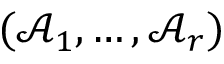<formula> <loc_0><loc_0><loc_500><loc_500>( { \mathcal { A } } _ { 1 } , \dots , { \mathcal { A } } _ { r } )</formula> 